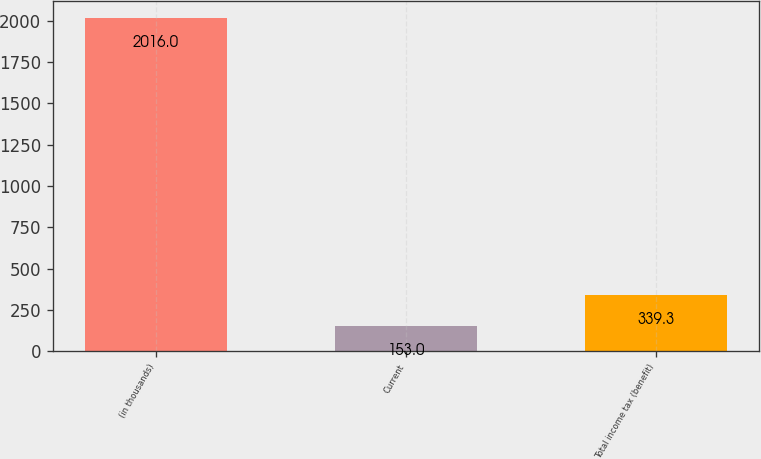Convert chart to OTSL. <chart><loc_0><loc_0><loc_500><loc_500><bar_chart><fcel>(in thousands)<fcel>Current<fcel>Total income tax (benefit)<nl><fcel>2016<fcel>153<fcel>339.3<nl></chart> 